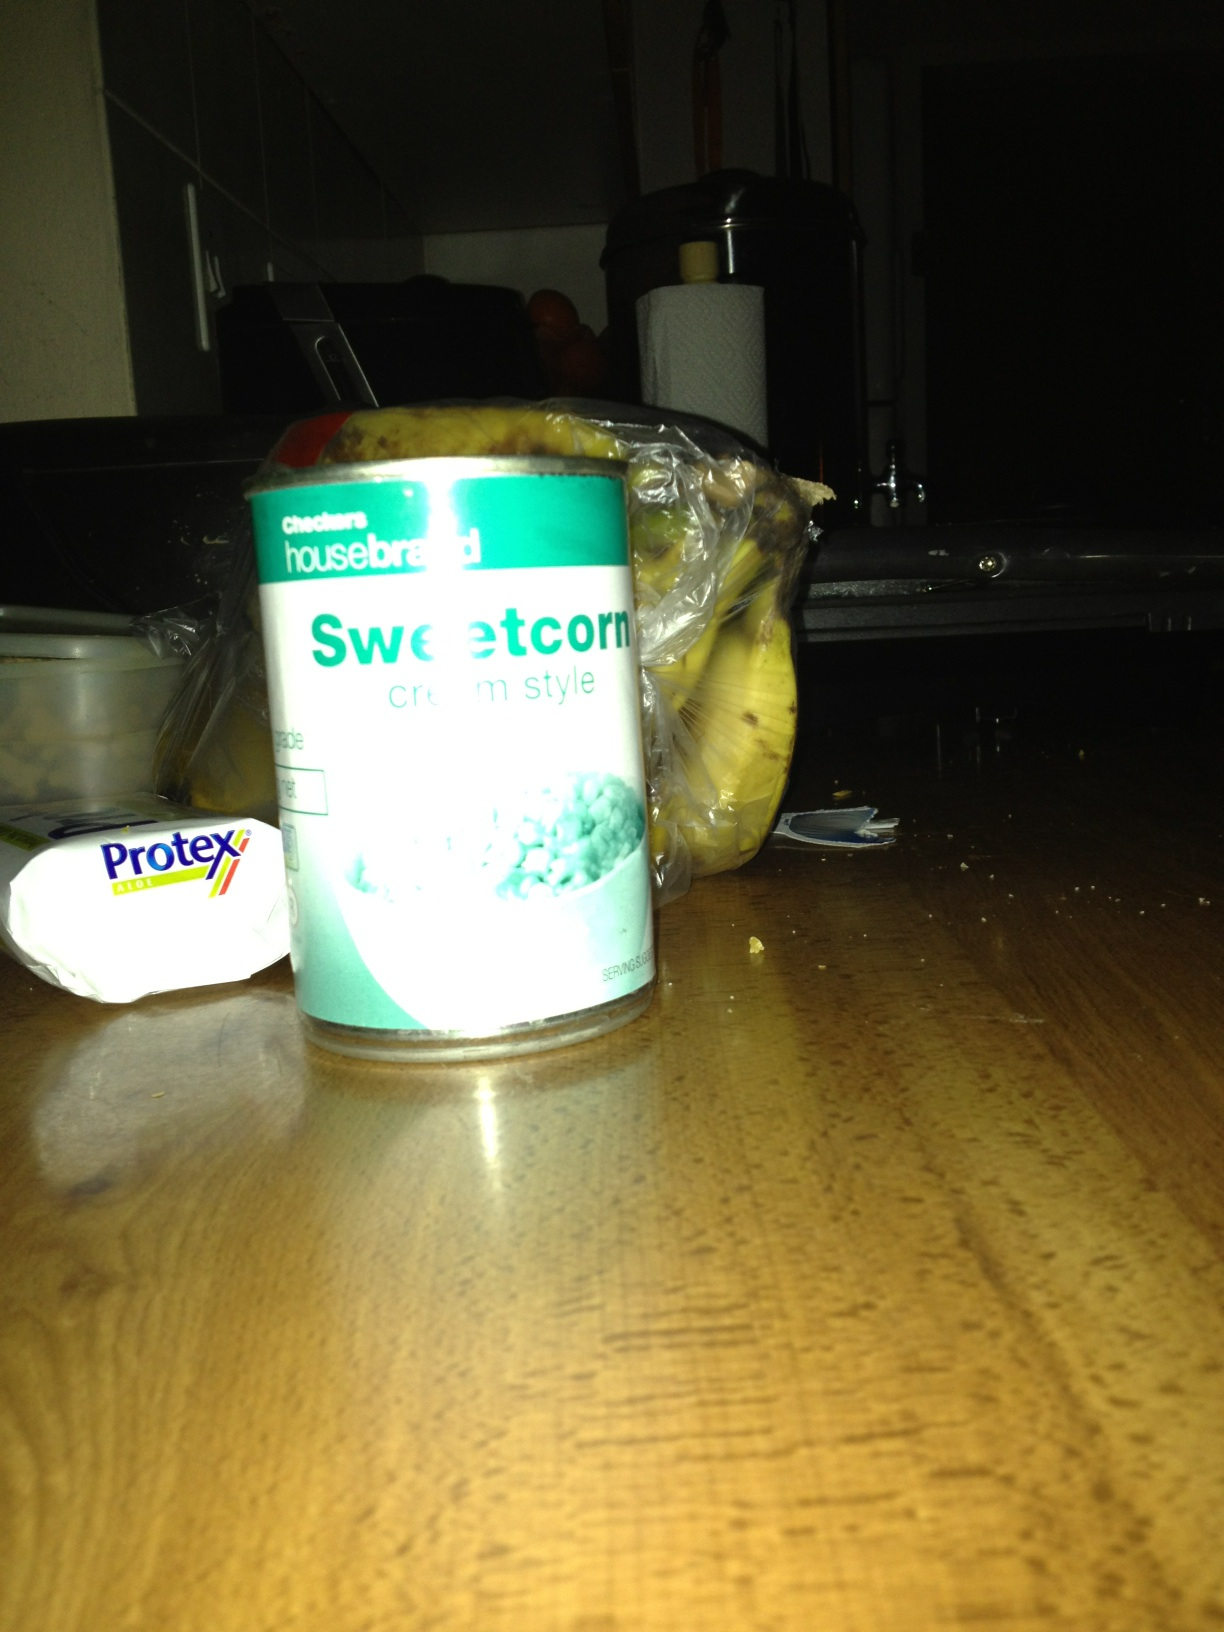Describe a realistic scenario where someone might use this can of sweetcorn in everyday life. A busy parent comes home from work and needs to prepare a quick dinner for the family. They decide to make a hearty chicken and sweetcorn soup. They grab the can of cream style sweetcorn from the pantry, a few other ingredients from the refrigerator, and within 30 minutes, they have a delicious, comforting meal on the table that everyone enjoys. 